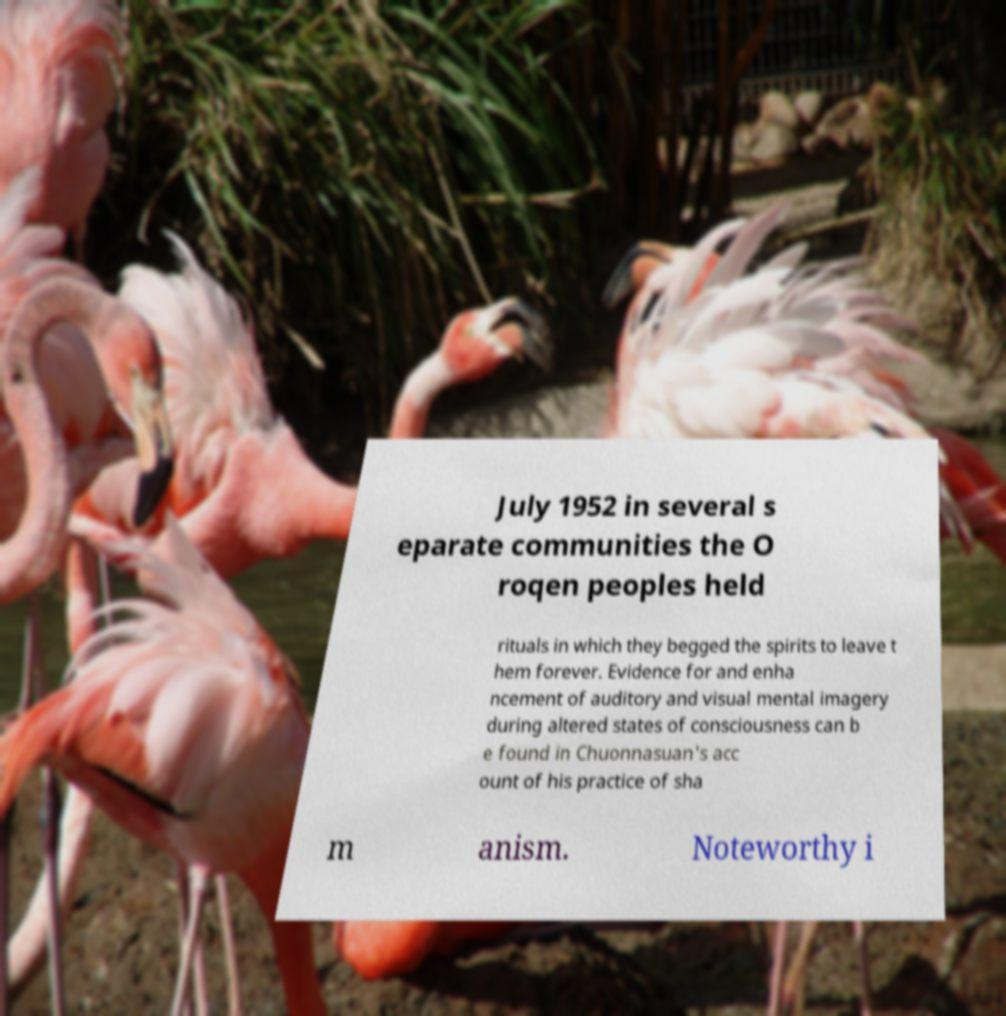Can you accurately transcribe the text from the provided image for me? July 1952 in several s eparate communities the O roqen peoples held rituals in which they begged the spirits to leave t hem forever. Evidence for and enha ncement of auditory and visual mental imagery during altered states of consciousness can b e found in Chuonnasuan's acc ount of his practice of sha m anism. Noteworthy i 